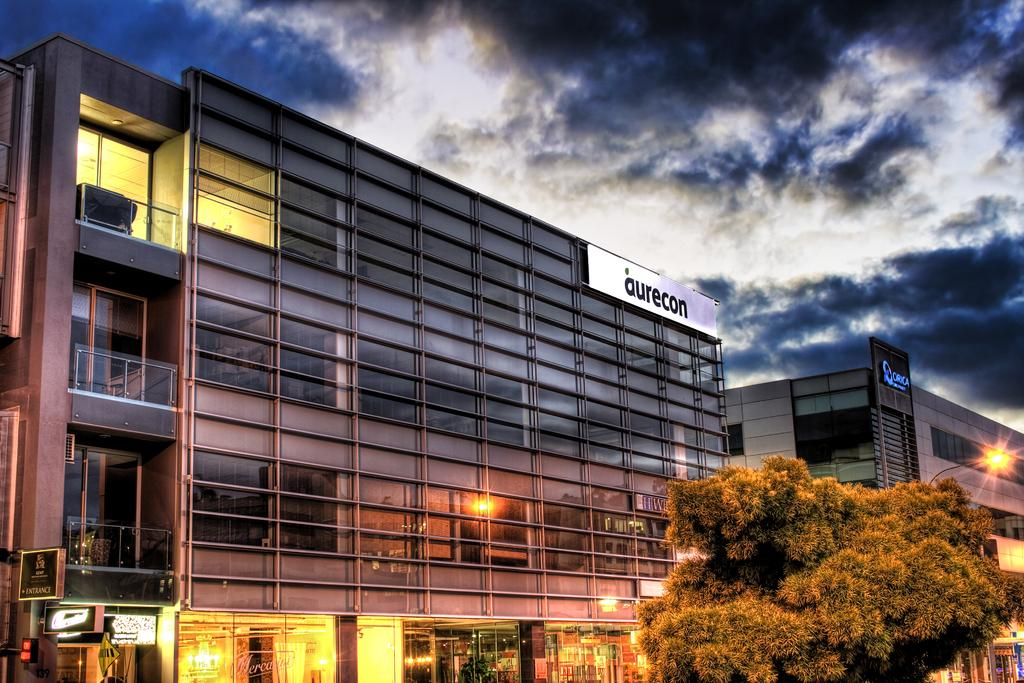What is located in the foreground of the image? There is a tree in the foreground of the image. What can be seen in the background of the image? There are two buildings, banners, lights, and the sky visible in the background of the image. Can you describe the cloud in the image? There is a cloud visible in the background of the image. Where is the volleyball court located in the image? There is no volleyball court present in the image. How deep is the quicksand near the tree in the image? There is no quicksand present in the image. 